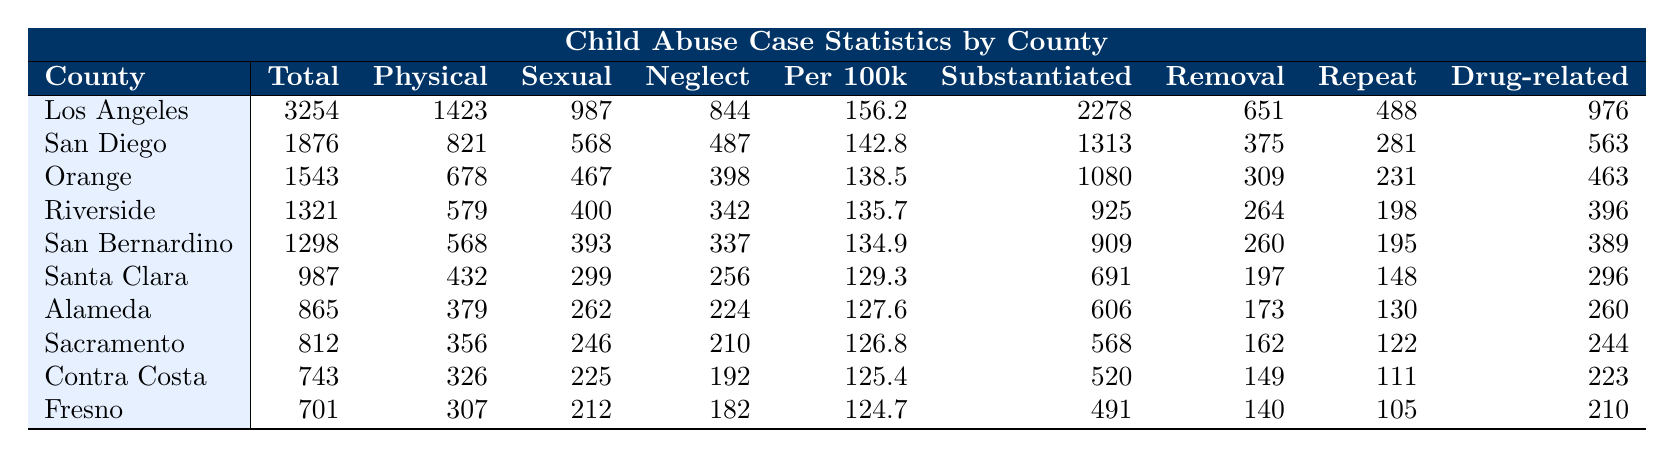What county has the highest total number of child abuse cases? By looking at the "Total" column, we can see that Los Angeles has 3254 cases, which is the highest total compared to the other counties listed.
Answer: Los Angeles How many cases of physical abuse were reported in San Diego? The "Physical" column indicates that there were 821 cases of physical abuse in San Diego.
Answer: 821 Which county reported the lowest number of cases resulting in removal? The "Removal" column shows that Fresno has the lowest number of cases resulting in removal, with a total of 140 cases.
Answer: Fresno What is the average number of sexual abuse cases across all ten counties? To find the average, we sum all sexual abuse cases: 987 + 568 + 467 + 400 + 393 + 299 + 262 + 246 + 225 + 212 = 4039. We then divide by the number of counties, which is 10. Therefore, the average is 4039 / 10 = 403.9.
Answer: 403.9 Is it true that San Bernardino had more cases of neglect than sexual abuse? By comparing the values in the "Neglect" and "Sexual" columns, we see that San Bernardino has 337 cases of neglect and 393 cases of sexual abuse. Since 337 is less than 393, the statement is false.
Answer: No What is the total number of repeat offenders in the top three counties? We add the repeat offenders for Los Angeles, San Diego, and Orange: 488 + 281 + 231 = 1000.
Answer: 1000 Which county had the highest number of cases involving drugs? In the "Drug-related" column, Los Angeles has 976 cases involving drugs, which is the highest among all counties.
Answer: Los Angeles Compare the number of substantiated cases between Riverside and Santa Clara. Which county had more? Riverside has 925 substantiated cases and Santa Clara has 691. Since 925 is greater than 691, Riverside had more substantiated cases.
Answer: Riverside What percentage of total cases in Alameda resulted in removal? To find the percentage, divide the number of cases resulting in removal (173) by the total cases (865) and multiply by 100. Thus, (173 / 865) * 100 = 20%.
Answer: 20% If we rank the counties by total cases, what is the rank of Sacramento? Sacramento comes eighth when all ten counties are ranked by total cases, as it has the eighth highest total number of 812 cases.
Answer: 8 